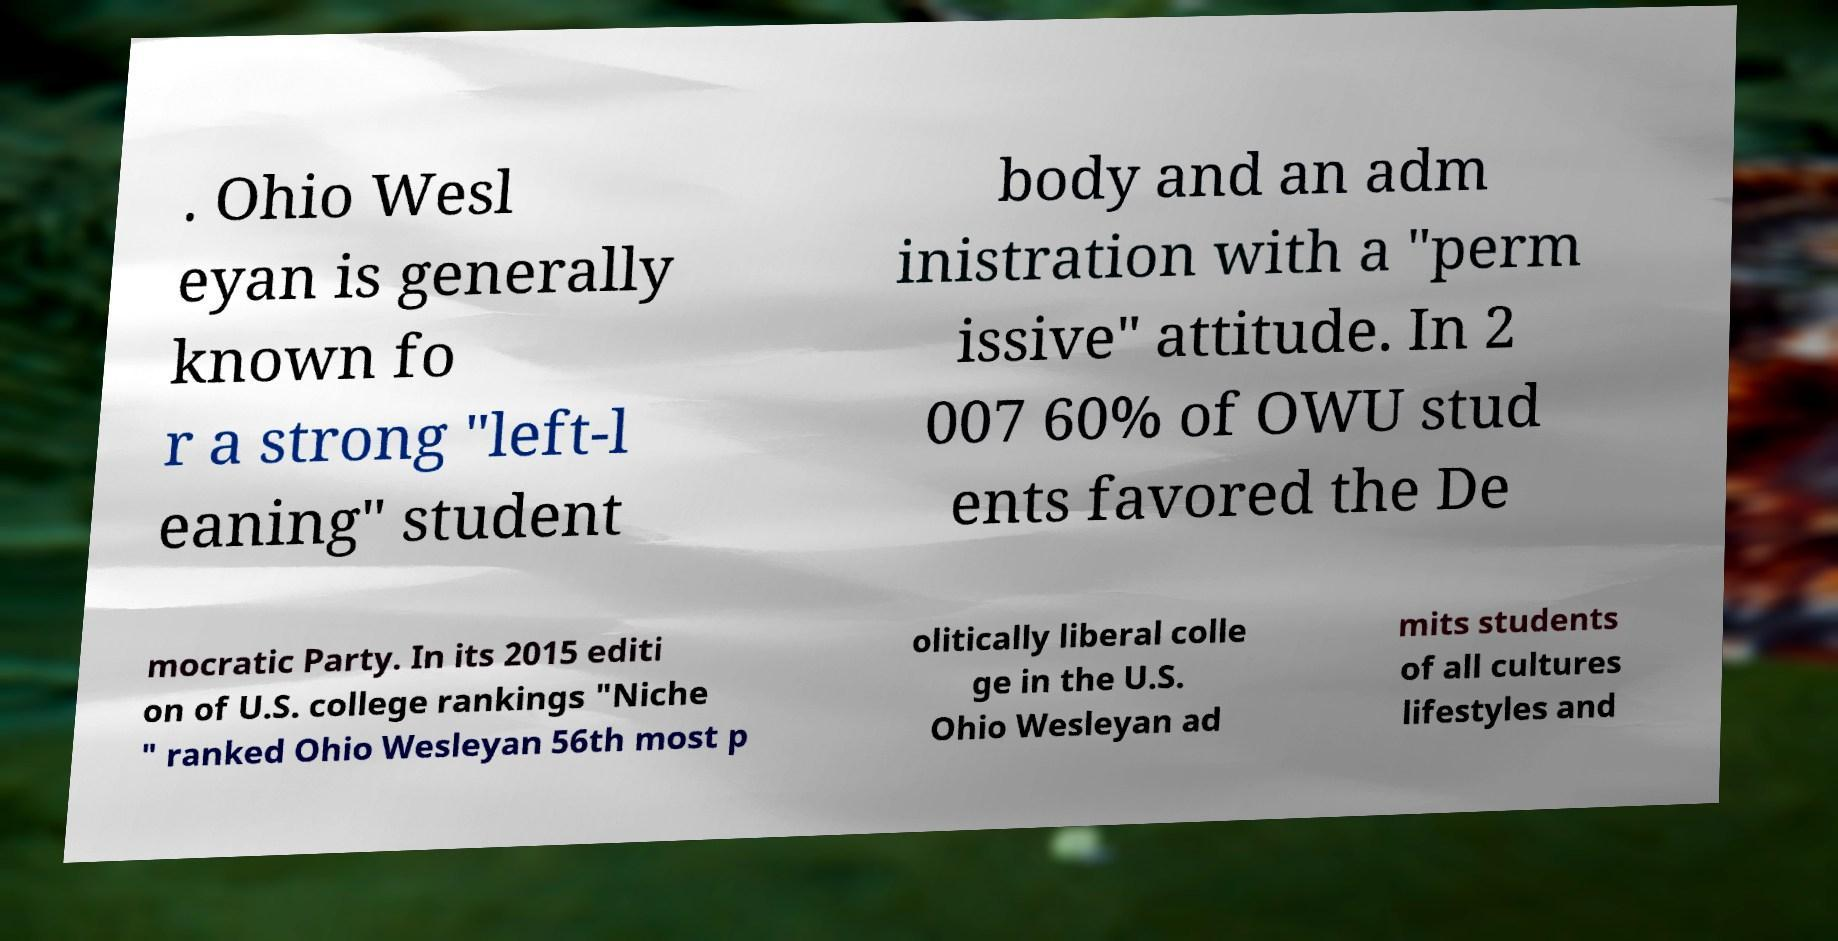Please identify and transcribe the text found in this image. . Ohio Wesl eyan is generally known fo r a strong "left-l eaning" student body and an adm inistration with a "perm issive" attitude. In 2 007 60% of OWU stud ents favored the De mocratic Party. In its 2015 editi on of U.S. college rankings "Niche " ranked Ohio Wesleyan 56th most p olitically liberal colle ge in the U.S. Ohio Wesleyan ad mits students of all cultures lifestyles and 